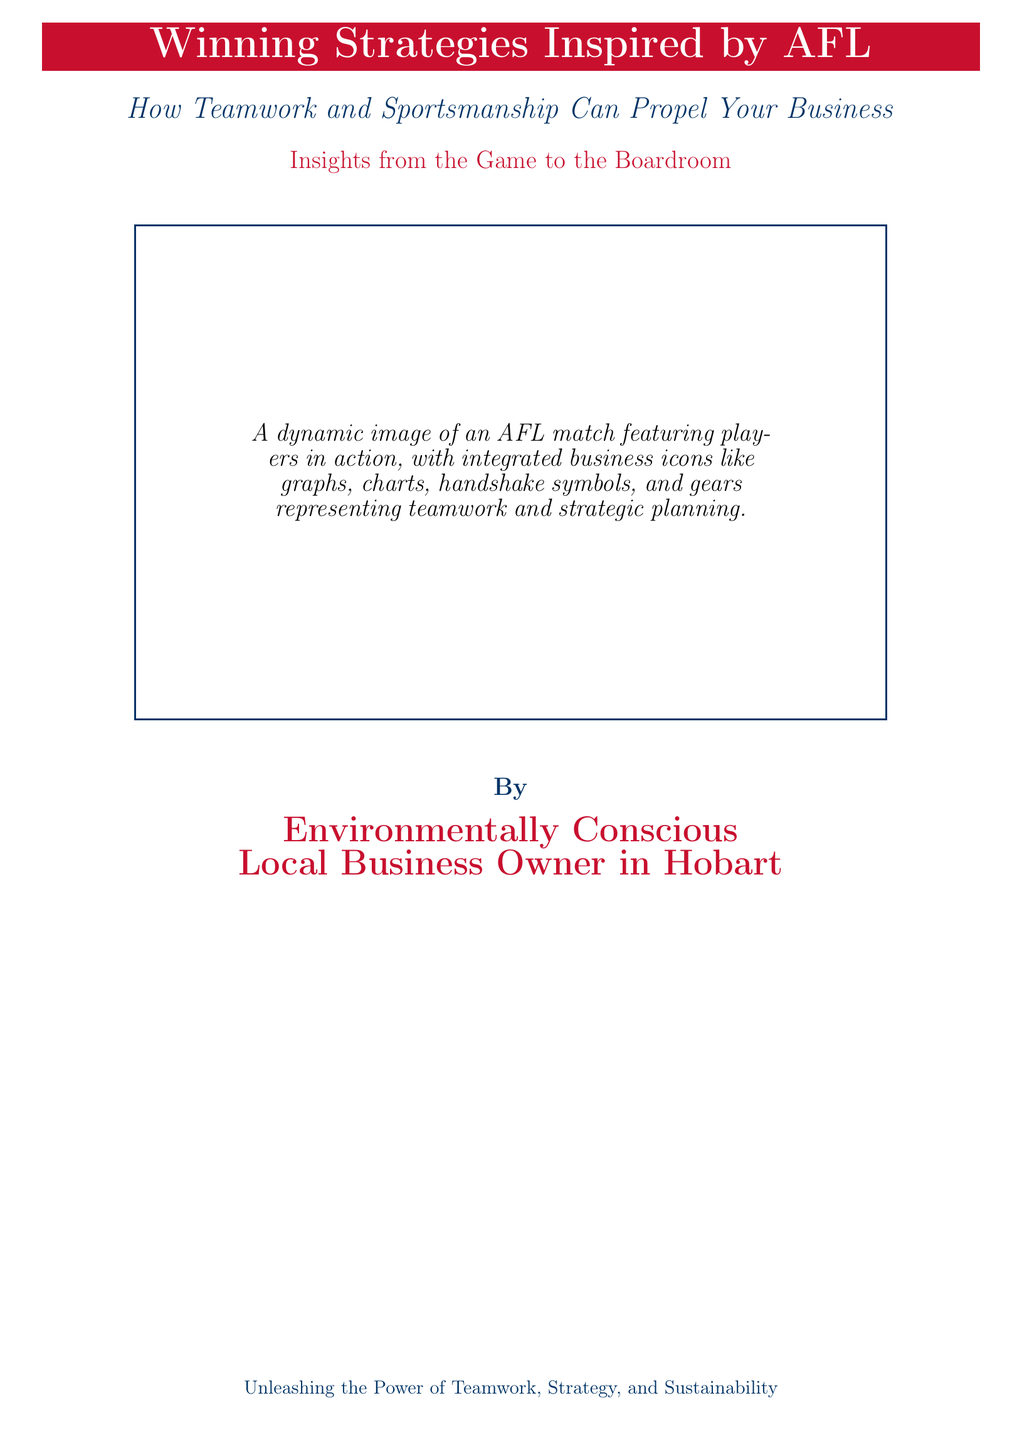What is the title of the book? The title is prominently displayed in large font on the cover.
Answer: Winning Strategies Inspired by AFL What does the subtitle emphasize? The subtitle highlights the themes of teamwork and sportsmanship.
Answer: How Teamwork and Sportsmanship Can Propel Your Business What color is used for the title? The title is in a color that stands out against the background.
Answer: Red What type of imagery is integrated into the cover? The document describes a specific kind of visual element linking sports to business.
Answer: Business icons Who is the author of the book? The author is identified at the bottom of the cover.
Answer: Environmentally Conscious Local Business Owner in Hobart What is the main theme reflected in the book? The book covers concepts relevant to professionals working in collaborative environments.
Answer: Teamwork, Strategy, and Sustainability What is the background color of the title box? The background color contrasts with the text color for visibility.
Answer: AFL Red How does the book relate AFL to business? It draws parallels between sportsmanship in AFL and business practices.
Answer: Insights from the Game to the Boardroom What element represents the strategic aspect of business? The visual elements represent business strategies and teamwork.
Answer: Gears and charts 